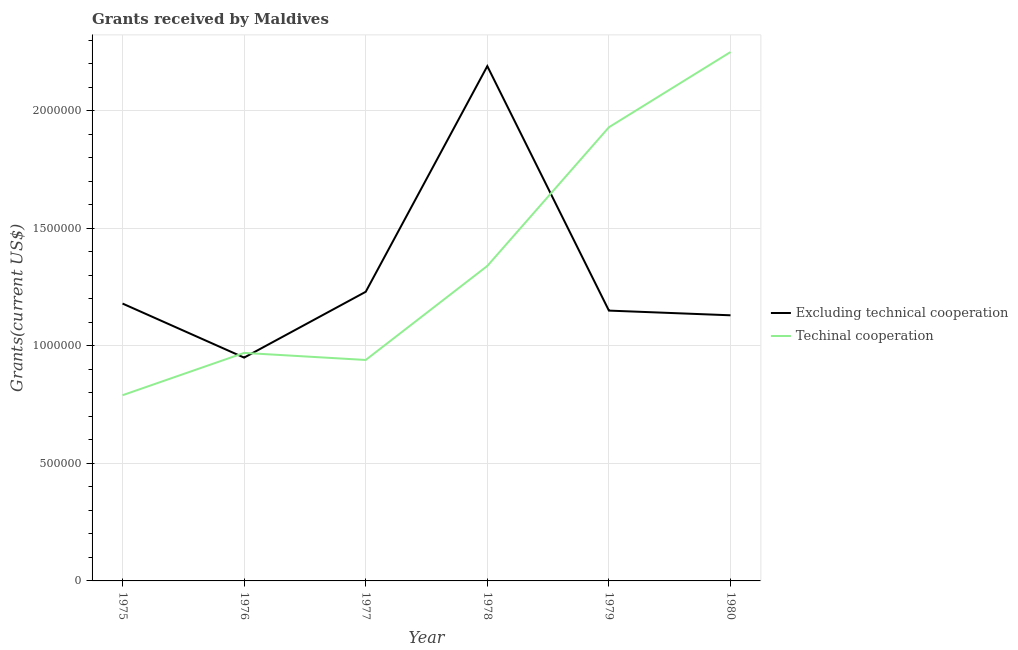How many different coloured lines are there?
Provide a short and direct response. 2. Is the number of lines equal to the number of legend labels?
Provide a short and direct response. Yes. What is the amount of grants received(excluding technical cooperation) in 1976?
Your answer should be compact. 9.50e+05. Across all years, what is the maximum amount of grants received(including technical cooperation)?
Provide a succinct answer. 2.25e+06. Across all years, what is the minimum amount of grants received(excluding technical cooperation)?
Your response must be concise. 9.50e+05. In which year was the amount of grants received(including technical cooperation) maximum?
Provide a succinct answer. 1980. In which year was the amount of grants received(excluding technical cooperation) minimum?
Your answer should be compact. 1976. What is the total amount of grants received(including technical cooperation) in the graph?
Offer a very short reply. 8.22e+06. What is the difference between the amount of grants received(including technical cooperation) in 1975 and that in 1977?
Your answer should be very brief. -1.50e+05. What is the difference between the amount of grants received(including technical cooperation) in 1975 and the amount of grants received(excluding technical cooperation) in 1977?
Your response must be concise. -4.40e+05. What is the average amount of grants received(including technical cooperation) per year?
Offer a terse response. 1.37e+06. In the year 1975, what is the difference between the amount of grants received(excluding technical cooperation) and amount of grants received(including technical cooperation)?
Give a very brief answer. 3.90e+05. In how many years, is the amount of grants received(including technical cooperation) greater than 800000 US$?
Your response must be concise. 5. What is the ratio of the amount of grants received(excluding technical cooperation) in 1978 to that in 1980?
Your response must be concise. 1.94. What is the difference between the highest and the second highest amount of grants received(excluding technical cooperation)?
Offer a very short reply. 9.60e+05. What is the difference between the highest and the lowest amount of grants received(excluding technical cooperation)?
Provide a short and direct response. 1.24e+06. In how many years, is the amount of grants received(excluding technical cooperation) greater than the average amount of grants received(excluding technical cooperation) taken over all years?
Provide a succinct answer. 1. Is the sum of the amount of grants received(excluding technical cooperation) in 1977 and 1979 greater than the maximum amount of grants received(including technical cooperation) across all years?
Your answer should be compact. Yes. Does the amount of grants received(excluding technical cooperation) monotonically increase over the years?
Make the answer very short. No. Is the amount of grants received(including technical cooperation) strictly less than the amount of grants received(excluding technical cooperation) over the years?
Make the answer very short. No. Are the values on the major ticks of Y-axis written in scientific E-notation?
Provide a short and direct response. No. Does the graph contain grids?
Provide a succinct answer. Yes. Where does the legend appear in the graph?
Provide a succinct answer. Center right. How are the legend labels stacked?
Offer a terse response. Vertical. What is the title of the graph?
Offer a very short reply. Grants received by Maldives. What is the label or title of the Y-axis?
Keep it short and to the point. Grants(current US$). What is the Grants(current US$) of Excluding technical cooperation in 1975?
Offer a terse response. 1.18e+06. What is the Grants(current US$) of Techinal cooperation in 1975?
Your answer should be very brief. 7.90e+05. What is the Grants(current US$) in Excluding technical cooperation in 1976?
Ensure brevity in your answer.  9.50e+05. What is the Grants(current US$) in Techinal cooperation in 1976?
Offer a very short reply. 9.70e+05. What is the Grants(current US$) of Excluding technical cooperation in 1977?
Provide a short and direct response. 1.23e+06. What is the Grants(current US$) of Techinal cooperation in 1977?
Offer a terse response. 9.40e+05. What is the Grants(current US$) of Excluding technical cooperation in 1978?
Give a very brief answer. 2.19e+06. What is the Grants(current US$) in Techinal cooperation in 1978?
Your answer should be compact. 1.34e+06. What is the Grants(current US$) in Excluding technical cooperation in 1979?
Offer a terse response. 1.15e+06. What is the Grants(current US$) of Techinal cooperation in 1979?
Offer a terse response. 1.93e+06. What is the Grants(current US$) of Excluding technical cooperation in 1980?
Offer a very short reply. 1.13e+06. What is the Grants(current US$) in Techinal cooperation in 1980?
Your answer should be very brief. 2.25e+06. Across all years, what is the maximum Grants(current US$) in Excluding technical cooperation?
Your answer should be very brief. 2.19e+06. Across all years, what is the maximum Grants(current US$) in Techinal cooperation?
Your response must be concise. 2.25e+06. Across all years, what is the minimum Grants(current US$) in Excluding technical cooperation?
Provide a short and direct response. 9.50e+05. Across all years, what is the minimum Grants(current US$) of Techinal cooperation?
Your answer should be compact. 7.90e+05. What is the total Grants(current US$) of Excluding technical cooperation in the graph?
Your answer should be compact. 7.83e+06. What is the total Grants(current US$) in Techinal cooperation in the graph?
Your response must be concise. 8.22e+06. What is the difference between the Grants(current US$) of Excluding technical cooperation in 1975 and that in 1977?
Keep it short and to the point. -5.00e+04. What is the difference between the Grants(current US$) in Excluding technical cooperation in 1975 and that in 1978?
Offer a very short reply. -1.01e+06. What is the difference between the Grants(current US$) in Techinal cooperation in 1975 and that in 1978?
Provide a succinct answer. -5.50e+05. What is the difference between the Grants(current US$) of Techinal cooperation in 1975 and that in 1979?
Offer a terse response. -1.14e+06. What is the difference between the Grants(current US$) in Techinal cooperation in 1975 and that in 1980?
Your answer should be very brief. -1.46e+06. What is the difference between the Grants(current US$) in Excluding technical cooperation in 1976 and that in 1977?
Offer a terse response. -2.80e+05. What is the difference between the Grants(current US$) in Techinal cooperation in 1976 and that in 1977?
Offer a terse response. 3.00e+04. What is the difference between the Grants(current US$) of Excluding technical cooperation in 1976 and that in 1978?
Give a very brief answer. -1.24e+06. What is the difference between the Grants(current US$) in Techinal cooperation in 1976 and that in 1978?
Give a very brief answer. -3.70e+05. What is the difference between the Grants(current US$) in Techinal cooperation in 1976 and that in 1979?
Your response must be concise. -9.60e+05. What is the difference between the Grants(current US$) in Excluding technical cooperation in 1976 and that in 1980?
Your answer should be compact. -1.80e+05. What is the difference between the Grants(current US$) of Techinal cooperation in 1976 and that in 1980?
Offer a terse response. -1.28e+06. What is the difference between the Grants(current US$) of Excluding technical cooperation in 1977 and that in 1978?
Ensure brevity in your answer.  -9.60e+05. What is the difference between the Grants(current US$) of Techinal cooperation in 1977 and that in 1978?
Your answer should be very brief. -4.00e+05. What is the difference between the Grants(current US$) in Techinal cooperation in 1977 and that in 1979?
Make the answer very short. -9.90e+05. What is the difference between the Grants(current US$) of Excluding technical cooperation in 1977 and that in 1980?
Ensure brevity in your answer.  1.00e+05. What is the difference between the Grants(current US$) of Techinal cooperation in 1977 and that in 1980?
Ensure brevity in your answer.  -1.31e+06. What is the difference between the Grants(current US$) in Excluding technical cooperation in 1978 and that in 1979?
Your answer should be compact. 1.04e+06. What is the difference between the Grants(current US$) in Techinal cooperation in 1978 and that in 1979?
Make the answer very short. -5.90e+05. What is the difference between the Grants(current US$) in Excluding technical cooperation in 1978 and that in 1980?
Offer a very short reply. 1.06e+06. What is the difference between the Grants(current US$) in Techinal cooperation in 1978 and that in 1980?
Provide a short and direct response. -9.10e+05. What is the difference between the Grants(current US$) of Techinal cooperation in 1979 and that in 1980?
Keep it short and to the point. -3.20e+05. What is the difference between the Grants(current US$) of Excluding technical cooperation in 1975 and the Grants(current US$) of Techinal cooperation in 1976?
Offer a terse response. 2.10e+05. What is the difference between the Grants(current US$) of Excluding technical cooperation in 1975 and the Grants(current US$) of Techinal cooperation in 1979?
Make the answer very short. -7.50e+05. What is the difference between the Grants(current US$) of Excluding technical cooperation in 1975 and the Grants(current US$) of Techinal cooperation in 1980?
Ensure brevity in your answer.  -1.07e+06. What is the difference between the Grants(current US$) in Excluding technical cooperation in 1976 and the Grants(current US$) in Techinal cooperation in 1978?
Provide a succinct answer. -3.90e+05. What is the difference between the Grants(current US$) of Excluding technical cooperation in 1976 and the Grants(current US$) of Techinal cooperation in 1979?
Your answer should be compact. -9.80e+05. What is the difference between the Grants(current US$) in Excluding technical cooperation in 1976 and the Grants(current US$) in Techinal cooperation in 1980?
Make the answer very short. -1.30e+06. What is the difference between the Grants(current US$) in Excluding technical cooperation in 1977 and the Grants(current US$) in Techinal cooperation in 1978?
Provide a succinct answer. -1.10e+05. What is the difference between the Grants(current US$) of Excluding technical cooperation in 1977 and the Grants(current US$) of Techinal cooperation in 1979?
Provide a short and direct response. -7.00e+05. What is the difference between the Grants(current US$) in Excluding technical cooperation in 1977 and the Grants(current US$) in Techinal cooperation in 1980?
Offer a very short reply. -1.02e+06. What is the difference between the Grants(current US$) of Excluding technical cooperation in 1979 and the Grants(current US$) of Techinal cooperation in 1980?
Provide a succinct answer. -1.10e+06. What is the average Grants(current US$) in Excluding technical cooperation per year?
Ensure brevity in your answer.  1.30e+06. What is the average Grants(current US$) in Techinal cooperation per year?
Your answer should be very brief. 1.37e+06. In the year 1978, what is the difference between the Grants(current US$) in Excluding technical cooperation and Grants(current US$) in Techinal cooperation?
Offer a very short reply. 8.50e+05. In the year 1979, what is the difference between the Grants(current US$) in Excluding technical cooperation and Grants(current US$) in Techinal cooperation?
Offer a terse response. -7.80e+05. In the year 1980, what is the difference between the Grants(current US$) of Excluding technical cooperation and Grants(current US$) of Techinal cooperation?
Keep it short and to the point. -1.12e+06. What is the ratio of the Grants(current US$) in Excluding technical cooperation in 1975 to that in 1976?
Provide a succinct answer. 1.24. What is the ratio of the Grants(current US$) of Techinal cooperation in 1975 to that in 1976?
Your response must be concise. 0.81. What is the ratio of the Grants(current US$) of Excluding technical cooperation in 1975 to that in 1977?
Your answer should be compact. 0.96. What is the ratio of the Grants(current US$) in Techinal cooperation in 1975 to that in 1977?
Your answer should be very brief. 0.84. What is the ratio of the Grants(current US$) of Excluding technical cooperation in 1975 to that in 1978?
Your response must be concise. 0.54. What is the ratio of the Grants(current US$) in Techinal cooperation in 1975 to that in 1978?
Offer a very short reply. 0.59. What is the ratio of the Grants(current US$) in Excluding technical cooperation in 1975 to that in 1979?
Provide a succinct answer. 1.03. What is the ratio of the Grants(current US$) in Techinal cooperation in 1975 to that in 1979?
Provide a succinct answer. 0.41. What is the ratio of the Grants(current US$) of Excluding technical cooperation in 1975 to that in 1980?
Provide a succinct answer. 1.04. What is the ratio of the Grants(current US$) in Techinal cooperation in 1975 to that in 1980?
Provide a succinct answer. 0.35. What is the ratio of the Grants(current US$) in Excluding technical cooperation in 1976 to that in 1977?
Provide a short and direct response. 0.77. What is the ratio of the Grants(current US$) of Techinal cooperation in 1976 to that in 1977?
Make the answer very short. 1.03. What is the ratio of the Grants(current US$) of Excluding technical cooperation in 1976 to that in 1978?
Provide a succinct answer. 0.43. What is the ratio of the Grants(current US$) in Techinal cooperation in 1976 to that in 1978?
Your answer should be very brief. 0.72. What is the ratio of the Grants(current US$) of Excluding technical cooperation in 1976 to that in 1979?
Provide a short and direct response. 0.83. What is the ratio of the Grants(current US$) in Techinal cooperation in 1976 to that in 1979?
Your answer should be very brief. 0.5. What is the ratio of the Grants(current US$) of Excluding technical cooperation in 1976 to that in 1980?
Offer a very short reply. 0.84. What is the ratio of the Grants(current US$) of Techinal cooperation in 1976 to that in 1980?
Offer a terse response. 0.43. What is the ratio of the Grants(current US$) in Excluding technical cooperation in 1977 to that in 1978?
Provide a short and direct response. 0.56. What is the ratio of the Grants(current US$) in Techinal cooperation in 1977 to that in 1978?
Provide a succinct answer. 0.7. What is the ratio of the Grants(current US$) in Excluding technical cooperation in 1977 to that in 1979?
Your response must be concise. 1.07. What is the ratio of the Grants(current US$) in Techinal cooperation in 1977 to that in 1979?
Keep it short and to the point. 0.49. What is the ratio of the Grants(current US$) in Excluding technical cooperation in 1977 to that in 1980?
Give a very brief answer. 1.09. What is the ratio of the Grants(current US$) in Techinal cooperation in 1977 to that in 1980?
Your answer should be compact. 0.42. What is the ratio of the Grants(current US$) in Excluding technical cooperation in 1978 to that in 1979?
Provide a short and direct response. 1.9. What is the ratio of the Grants(current US$) in Techinal cooperation in 1978 to that in 1979?
Offer a terse response. 0.69. What is the ratio of the Grants(current US$) in Excluding technical cooperation in 1978 to that in 1980?
Provide a short and direct response. 1.94. What is the ratio of the Grants(current US$) in Techinal cooperation in 1978 to that in 1980?
Provide a short and direct response. 0.6. What is the ratio of the Grants(current US$) of Excluding technical cooperation in 1979 to that in 1980?
Ensure brevity in your answer.  1.02. What is the ratio of the Grants(current US$) of Techinal cooperation in 1979 to that in 1980?
Your response must be concise. 0.86. What is the difference between the highest and the second highest Grants(current US$) of Excluding technical cooperation?
Make the answer very short. 9.60e+05. What is the difference between the highest and the second highest Grants(current US$) in Techinal cooperation?
Make the answer very short. 3.20e+05. What is the difference between the highest and the lowest Grants(current US$) in Excluding technical cooperation?
Offer a very short reply. 1.24e+06. What is the difference between the highest and the lowest Grants(current US$) of Techinal cooperation?
Provide a short and direct response. 1.46e+06. 